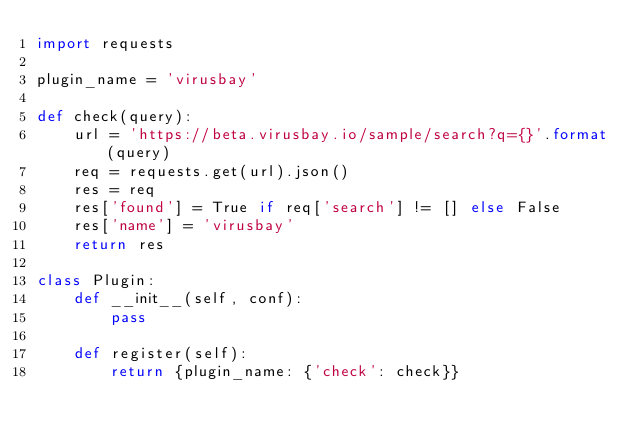<code> <loc_0><loc_0><loc_500><loc_500><_Python_>import requests

plugin_name = 'virusbay'

def check(query):
    url = 'https://beta.virusbay.io/sample/search?q={}'.format(query)
    req = requests.get(url).json()
    res = req
    res['found'] = True if req['search'] != [] else False
    res['name'] = 'virusbay'
    return res

class Plugin:
    def __init__(self, conf):
        pass

    def register(self):
        return {plugin_name: {'check': check}}
</code> 